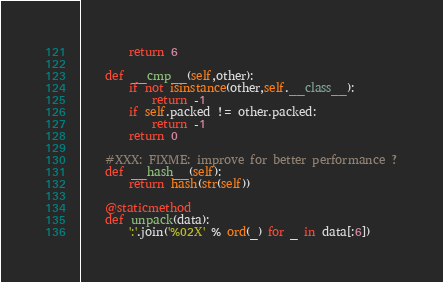<code> <loc_0><loc_0><loc_500><loc_500><_Python_>		return 6

	def __cmp__(self,other):
		if not isinstance(other,self.__class__):
			return -1
		if self.packed != other.packed:
			return -1
		return 0

	#XXX: FIXME: improve for better performance ?
	def __hash__(self):
		return hash(str(self))

	@staticmethod
	def unpack(data):
		':'.join('%02X' % ord(_) for _ in data[:6])
</code> 